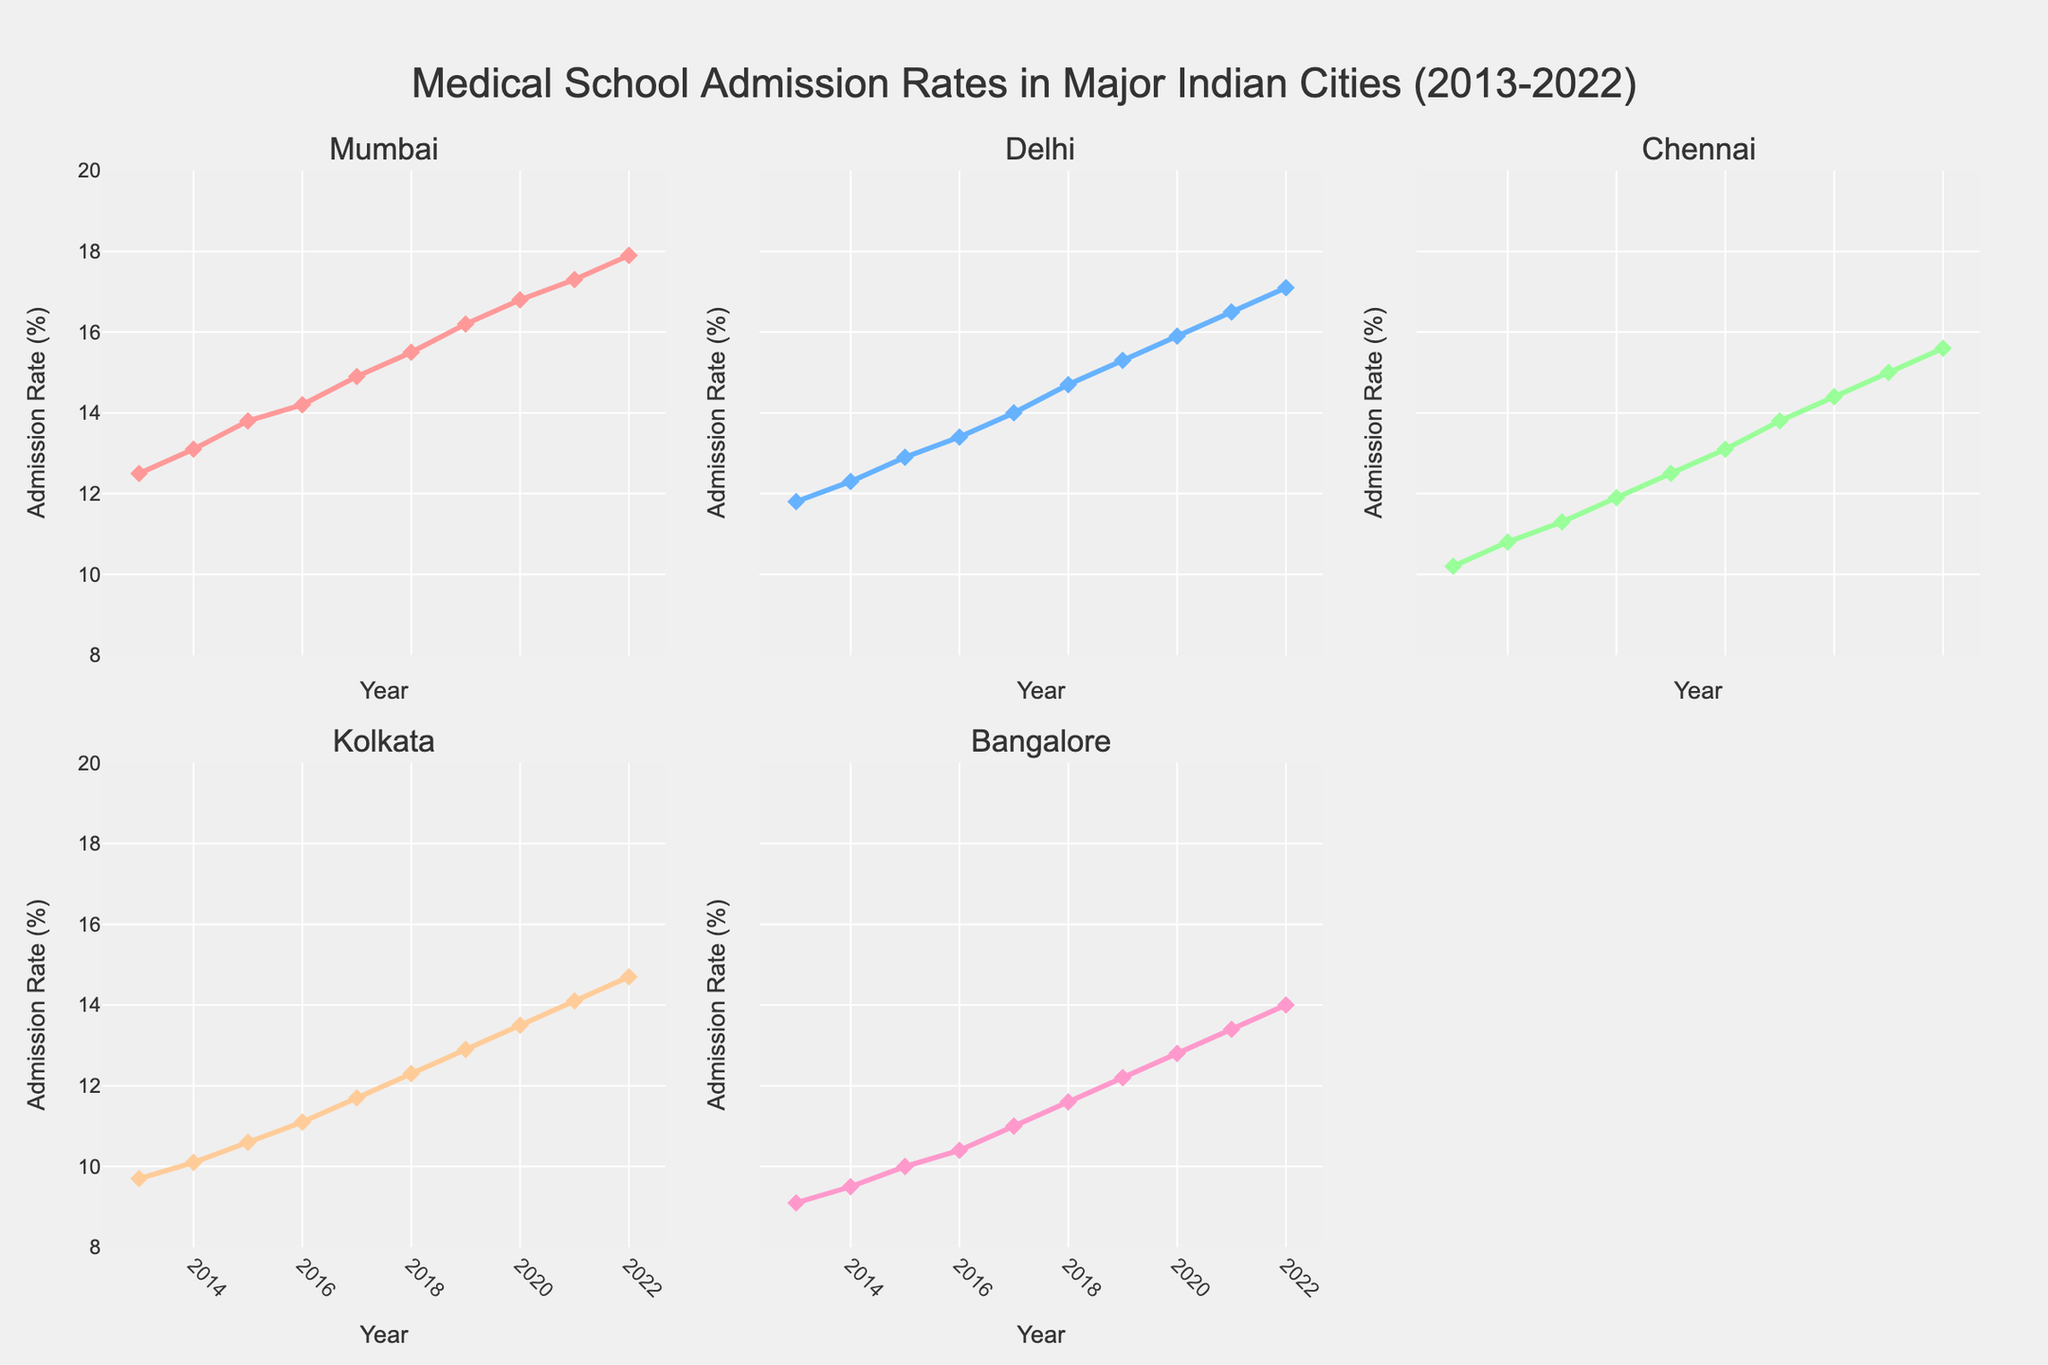What is the overall trend in medical school admission rates for Mumbai from 2013 to 2022? By observing the plot for Mumbai, we can see that the admission rates are steadily increasing each year, starting from around 12.5% in 2013 and reaching close to 17.9% in 2022.
Answer: Steadily increasing Which city had the highest admission rate in 2022? By examining the subplots, we can compare the terminal points for each city in 2022. Mumbai's admission rate is the highest at 17.9%.
Answer: Mumbai In which year did Bangalore's admission rate first exceed 10%? Looking at Bangalore's subplot, the admission rate crosses 10% between 2015 and 2016. So, the first year it exceeds 10% is 2016.
Answer: 2016 What is the difference in admission rate between Delhi and Chennai in 2017? In 2017, the admission rate for Delhi was 14.0%, and for Chennai, it was 12.5%. The difference is 14.0% - 12.5% = 1.5%.
Answer: 1.5% How many lines are plotted in each subplot? By counting the lines in any of the subplots, we can see that only one line is plotted in each subplot, representing the admission rates of one city over time.
Answer: One Which city's admission rates showed the least growth over the decade? By comparing the overall change in the subplots, we see that Kolkata had the least growth, increasing from 9.7% in 2013 to 14.7% in 2022.
Answer: Kolkata Which cities had admission rates over 15% by 2020? We need to identify cities whose admission rates exceeded 15% in 2020. In 2020, both Mumbai (16.8%) and Delhi (15.9%) exceeded 15%.
Answer: Mumbai, Delhi Among the five cities, which exhibited the most consistent year-on-year increase in admission rates? Observing the plots, Mumbai shows a consistent and steady increase each year from 2013 to 2022 without any dips or fluctuations.
Answer: Mumbai What was the average admission rate for Chennai over the decade? Summing up Chennai's rates from 2013 to 2022 (10.2, 10.8, 11.3, 11.9, 12.5, 13.1, 13.8, 14.4, 15.0, 15.6) and dividing by 10, the average is (10.2+10.8+11.3+11.9+12.5+13.1+13.8+14.4+15.0+15.6)/10 = 12.86%.
Answer: 12.86% Which year's datapoints show the smallest variation in admission rates across all cities? Checking the range of values for each year, 2013 has the smallest variation, with rates from 9.1% (Bangalore) to 12.5% (Mumbai), a spread of 3.4%.
Answer: 2013 